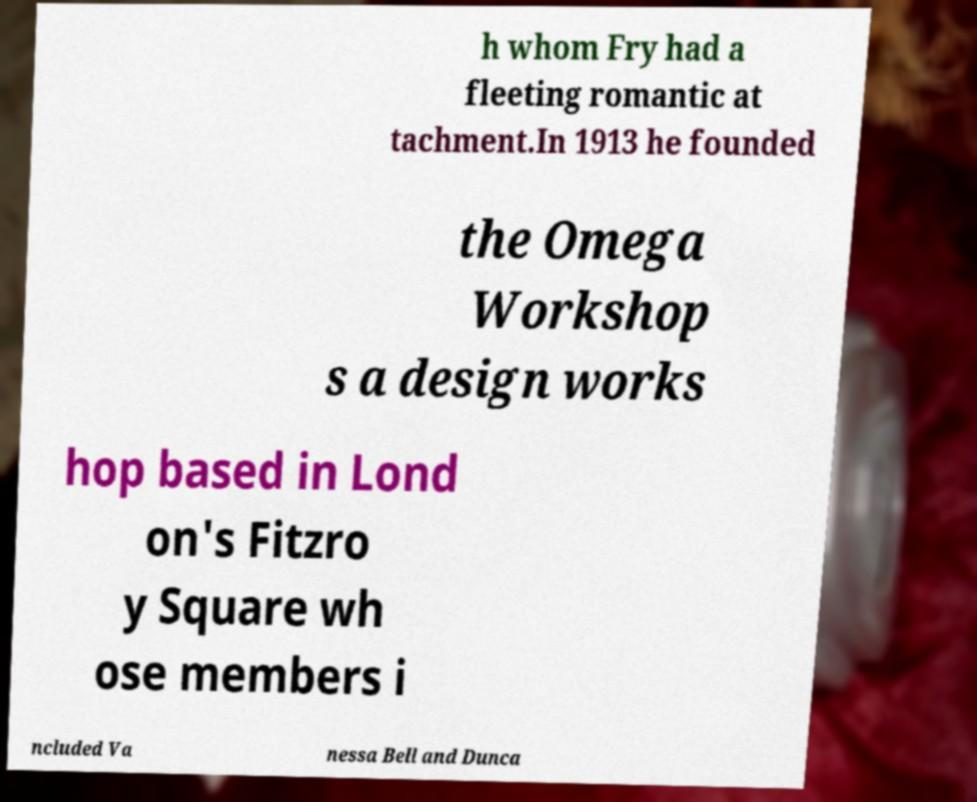Please identify and transcribe the text found in this image. h whom Fry had a fleeting romantic at tachment.In 1913 he founded the Omega Workshop s a design works hop based in Lond on's Fitzro y Square wh ose members i ncluded Va nessa Bell and Dunca 